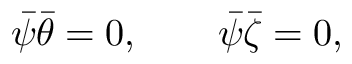Convert formula to latex. <formula><loc_0><loc_0><loc_500><loc_500>\bar { \psi } \bar { \theta } = 0 , \quad \bar { \psi } \bar { \zeta } = 0 ,</formula> 